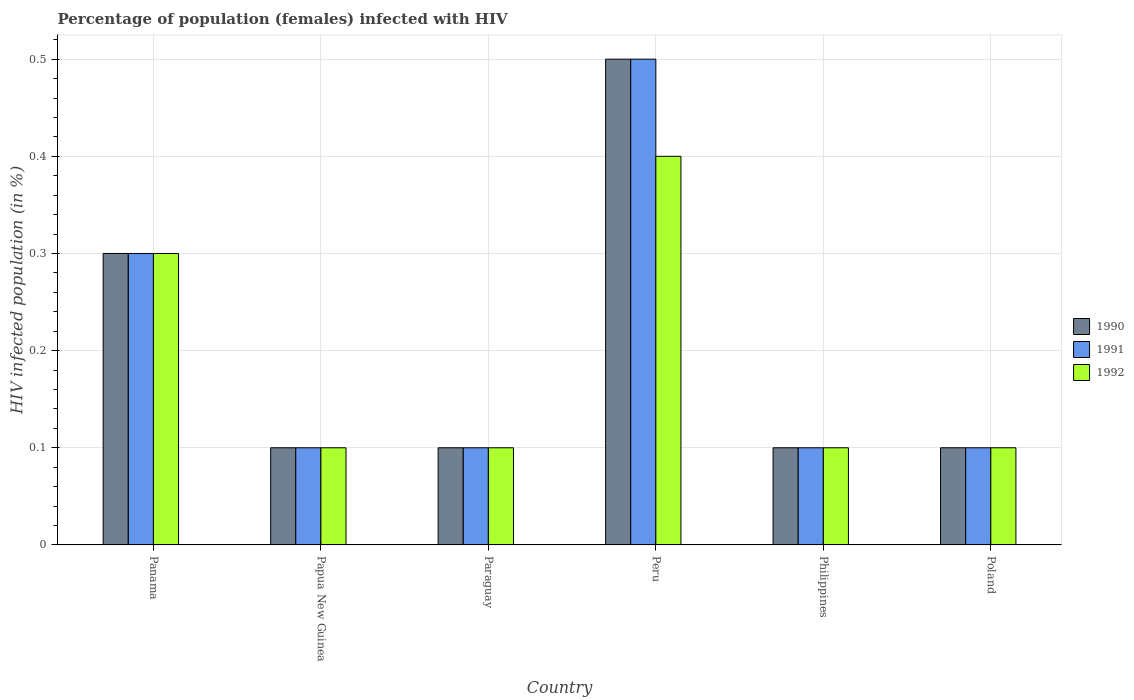How many different coloured bars are there?
Your answer should be compact. 3. What is the label of the 2nd group of bars from the left?
Ensure brevity in your answer.  Papua New Guinea. In how many cases, is the number of bars for a given country not equal to the number of legend labels?
Give a very brief answer. 0. Across all countries, what is the maximum percentage of HIV infected female population in 1990?
Provide a succinct answer. 0.5. In which country was the percentage of HIV infected female population in 1992 minimum?
Keep it short and to the point. Papua New Guinea. What is the average percentage of HIV infected female population in 1991 per country?
Your answer should be compact. 0.2. In how many countries, is the percentage of HIV infected female population in 1992 greater than 0.18 %?
Your response must be concise. 2. What is the ratio of the percentage of HIV infected female population in 1991 in Papua New Guinea to that in Philippines?
Keep it short and to the point. 1. What is the difference between the highest and the lowest percentage of HIV infected female population in 1992?
Your response must be concise. 0.3. In how many countries, is the percentage of HIV infected female population in 1992 greater than the average percentage of HIV infected female population in 1992 taken over all countries?
Your answer should be compact. 2. Is the sum of the percentage of HIV infected female population in 1991 in Panama and Paraguay greater than the maximum percentage of HIV infected female population in 1990 across all countries?
Keep it short and to the point. No. What does the 1st bar from the left in Peru represents?
Offer a terse response. 1990. What does the 2nd bar from the right in Paraguay represents?
Make the answer very short. 1991. How many bars are there?
Your answer should be very brief. 18. Are all the bars in the graph horizontal?
Ensure brevity in your answer.  No. Are the values on the major ticks of Y-axis written in scientific E-notation?
Provide a succinct answer. No. Where does the legend appear in the graph?
Provide a short and direct response. Center right. How are the legend labels stacked?
Provide a short and direct response. Vertical. What is the title of the graph?
Ensure brevity in your answer.  Percentage of population (females) infected with HIV. What is the label or title of the Y-axis?
Your answer should be compact. HIV infected population (in %). What is the HIV infected population (in %) of 1990 in Panama?
Give a very brief answer. 0.3. What is the HIV infected population (in %) of 1991 in Panama?
Ensure brevity in your answer.  0.3. What is the HIV infected population (in %) in 1992 in Panama?
Offer a terse response. 0.3. What is the HIV infected population (in %) in 1990 in Papua New Guinea?
Give a very brief answer. 0.1. What is the HIV infected population (in %) of 1991 in Papua New Guinea?
Your answer should be very brief. 0.1. What is the HIV infected population (in %) of 1992 in Papua New Guinea?
Your response must be concise. 0.1. What is the HIV infected population (in %) of 1990 in Paraguay?
Keep it short and to the point. 0.1. What is the HIV infected population (in %) of 1991 in Paraguay?
Provide a short and direct response. 0.1. What is the HIV infected population (in %) of 1990 in Peru?
Your answer should be compact. 0.5. What is the HIV infected population (in %) of 1992 in Peru?
Your answer should be very brief. 0.4. What is the HIV infected population (in %) of 1991 in Philippines?
Keep it short and to the point. 0.1. What is the HIV infected population (in %) in 1992 in Philippines?
Your answer should be very brief. 0.1. What is the HIV infected population (in %) of 1990 in Poland?
Provide a succinct answer. 0.1. What is the HIV infected population (in %) of 1992 in Poland?
Keep it short and to the point. 0.1. Across all countries, what is the maximum HIV infected population (in %) of 1990?
Keep it short and to the point. 0.5. Across all countries, what is the minimum HIV infected population (in %) in 1990?
Offer a very short reply. 0.1. Across all countries, what is the minimum HIV infected population (in %) of 1991?
Give a very brief answer. 0.1. What is the total HIV infected population (in %) of 1990 in the graph?
Make the answer very short. 1.2. What is the difference between the HIV infected population (in %) in 1990 in Panama and that in Peru?
Your response must be concise. -0.2. What is the difference between the HIV infected population (in %) in 1991 in Panama and that in Peru?
Offer a terse response. -0.2. What is the difference between the HIV infected population (in %) in 1992 in Panama and that in Philippines?
Your answer should be compact. 0.2. What is the difference between the HIV infected population (in %) of 1991 in Panama and that in Poland?
Ensure brevity in your answer.  0.2. What is the difference between the HIV infected population (in %) in 1992 in Papua New Guinea and that in Paraguay?
Give a very brief answer. 0. What is the difference between the HIV infected population (in %) in 1991 in Papua New Guinea and that in Peru?
Provide a short and direct response. -0.4. What is the difference between the HIV infected population (in %) in 1992 in Papua New Guinea and that in Peru?
Provide a short and direct response. -0.3. What is the difference between the HIV infected population (in %) in 1990 in Papua New Guinea and that in Philippines?
Offer a very short reply. 0. What is the difference between the HIV infected population (in %) in 1992 in Papua New Guinea and that in Philippines?
Provide a short and direct response. 0. What is the difference between the HIV infected population (in %) of 1992 in Papua New Guinea and that in Poland?
Make the answer very short. 0. What is the difference between the HIV infected population (in %) in 1990 in Paraguay and that in Peru?
Offer a terse response. -0.4. What is the difference between the HIV infected population (in %) of 1991 in Paraguay and that in Peru?
Provide a succinct answer. -0.4. What is the difference between the HIV infected population (in %) in 1992 in Paraguay and that in Peru?
Ensure brevity in your answer.  -0.3. What is the difference between the HIV infected population (in %) of 1991 in Paraguay and that in Poland?
Offer a very short reply. 0. What is the difference between the HIV infected population (in %) in 1992 in Peru and that in Philippines?
Your response must be concise. 0.3. What is the difference between the HIV infected population (in %) of 1991 in Peru and that in Poland?
Offer a very short reply. 0.4. What is the difference between the HIV infected population (in %) in 1992 in Peru and that in Poland?
Give a very brief answer. 0.3. What is the difference between the HIV infected population (in %) of 1990 in Philippines and that in Poland?
Offer a very short reply. 0. What is the difference between the HIV infected population (in %) of 1991 in Philippines and that in Poland?
Give a very brief answer. 0. What is the difference between the HIV infected population (in %) in 1992 in Philippines and that in Poland?
Ensure brevity in your answer.  0. What is the difference between the HIV infected population (in %) in 1991 in Panama and the HIV infected population (in %) in 1992 in Papua New Guinea?
Keep it short and to the point. 0.2. What is the difference between the HIV infected population (in %) of 1990 in Panama and the HIV infected population (in %) of 1991 in Peru?
Make the answer very short. -0.2. What is the difference between the HIV infected population (in %) in 1990 in Panama and the HIV infected population (in %) in 1992 in Peru?
Your answer should be very brief. -0.1. What is the difference between the HIV infected population (in %) of 1991 in Panama and the HIV infected population (in %) of 1992 in Peru?
Make the answer very short. -0.1. What is the difference between the HIV infected population (in %) of 1990 in Panama and the HIV infected population (in %) of 1991 in Philippines?
Ensure brevity in your answer.  0.2. What is the difference between the HIV infected population (in %) of 1990 in Panama and the HIV infected population (in %) of 1991 in Poland?
Your answer should be very brief. 0.2. What is the difference between the HIV infected population (in %) of 1990 in Papua New Guinea and the HIV infected population (in %) of 1991 in Philippines?
Offer a terse response. 0. What is the difference between the HIV infected population (in %) in 1990 in Papua New Guinea and the HIV infected population (in %) in 1992 in Philippines?
Offer a terse response. 0. What is the difference between the HIV infected population (in %) in 1990 in Papua New Guinea and the HIV infected population (in %) in 1992 in Poland?
Provide a short and direct response. 0. What is the difference between the HIV infected population (in %) in 1990 in Paraguay and the HIV infected population (in %) in 1992 in Peru?
Provide a short and direct response. -0.3. What is the difference between the HIV infected population (in %) in 1990 in Paraguay and the HIV infected population (in %) in 1991 in Poland?
Your answer should be very brief. 0. What is the difference between the HIV infected population (in %) in 1990 in Paraguay and the HIV infected population (in %) in 1992 in Poland?
Offer a terse response. 0. What is the difference between the HIV infected population (in %) in 1991 in Paraguay and the HIV infected population (in %) in 1992 in Poland?
Your answer should be very brief. 0. What is the difference between the HIV infected population (in %) in 1990 in Peru and the HIV infected population (in %) in 1991 in Philippines?
Your response must be concise. 0.4. What is the difference between the HIV infected population (in %) of 1990 in Peru and the HIV infected population (in %) of 1991 in Poland?
Provide a short and direct response. 0.4. What is the difference between the HIV infected population (in %) of 1991 in Peru and the HIV infected population (in %) of 1992 in Poland?
Keep it short and to the point. 0.4. What is the difference between the HIV infected population (in %) in 1990 in Philippines and the HIV infected population (in %) in 1991 in Poland?
Your answer should be compact. 0. What is the average HIV infected population (in %) of 1992 per country?
Provide a succinct answer. 0.18. What is the difference between the HIV infected population (in %) of 1990 and HIV infected population (in %) of 1991 in Panama?
Make the answer very short. 0. What is the difference between the HIV infected population (in %) of 1990 and HIV infected population (in %) of 1992 in Panama?
Your answer should be very brief. 0. What is the difference between the HIV infected population (in %) in 1991 and HIV infected population (in %) in 1992 in Panama?
Your response must be concise. 0. What is the difference between the HIV infected population (in %) of 1990 and HIV infected population (in %) of 1991 in Papua New Guinea?
Offer a terse response. 0. What is the difference between the HIV infected population (in %) in 1990 and HIV infected population (in %) in 1992 in Papua New Guinea?
Keep it short and to the point. 0. What is the difference between the HIV infected population (in %) of 1991 and HIV infected population (in %) of 1992 in Papua New Guinea?
Provide a succinct answer. 0. What is the difference between the HIV infected population (in %) in 1990 and HIV infected population (in %) in 1991 in Paraguay?
Offer a terse response. 0. What is the difference between the HIV infected population (in %) of 1990 and HIV infected population (in %) of 1992 in Paraguay?
Offer a terse response. 0. What is the difference between the HIV infected population (in %) of 1991 and HIV infected population (in %) of 1992 in Paraguay?
Keep it short and to the point. 0. What is the difference between the HIV infected population (in %) of 1990 and HIV infected population (in %) of 1992 in Peru?
Make the answer very short. 0.1. What is the difference between the HIV infected population (in %) of 1991 and HIV infected population (in %) of 1992 in Peru?
Ensure brevity in your answer.  0.1. What is the difference between the HIV infected population (in %) in 1990 and HIV infected population (in %) in 1991 in Philippines?
Offer a very short reply. 0. What is the difference between the HIV infected population (in %) of 1991 and HIV infected population (in %) of 1992 in Philippines?
Give a very brief answer. 0. What is the difference between the HIV infected population (in %) of 1990 and HIV infected population (in %) of 1992 in Poland?
Your answer should be very brief. 0. What is the ratio of the HIV infected population (in %) of 1992 in Panama to that in Papua New Guinea?
Provide a short and direct response. 3. What is the ratio of the HIV infected population (in %) of 1992 in Panama to that in Paraguay?
Your answer should be compact. 3. What is the ratio of the HIV infected population (in %) in 1991 in Panama to that in Philippines?
Offer a terse response. 3. What is the ratio of the HIV infected population (in %) of 1992 in Panama to that in Philippines?
Ensure brevity in your answer.  3. What is the ratio of the HIV infected population (in %) of 1991 in Panama to that in Poland?
Ensure brevity in your answer.  3. What is the ratio of the HIV infected population (in %) of 1990 in Papua New Guinea to that in Paraguay?
Provide a short and direct response. 1. What is the ratio of the HIV infected population (in %) in 1990 in Papua New Guinea to that in Peru?
Your answer should be compact. 0.2. What is the ratio of the HIV infected population (in %) in 1991 in Papua New Guinea to that in Peru?
Your answer should be compact. 0.2. What is the ratio of the HIV infected population (in %) of 1992 in Papua New Guinea to that in Peru?
Make the answer very short. 0.25. What is the ratio of the HIV infected population (in %) of 1990 in Papua New Guinea to that in Philippines?
Provide a short and direct response. 1. What is the ratio of the HIV infected population (in %) of 1991 in Papua New Guinea to that in Poland?
Provide a succinct answer. 1. What is the ratio of the HIV infected population (in %) in 1992 in Papua New Guinea to that in Poland?
Give a very brief answer. 1. What is the ratio of the HIV infected population (in %) in 1991 in Paraguay to that in Peru?
Keep it short and to the point. 0.2. What is the ratio of the HIV infected population (in %) in 1990 in Paraguay to that in Philippines?
Your response must be concise. 1. What is the ratio of the HIV infected population (in %) in 1992 in Paraguay to that in Poland?
Your response must be concise. 1. What is the ratio of the HIV infected population (in %) in 1990 in Peru to that in Philippines?
Your answer should be compact. 5. What is the ratio of the HIV infected population (in %) of 1991 in Peru to that in Philippines?
Offer a terse response. 5. What is the ratio of the HIV infected population (in %) of 1992 in Peru to that in Philippines?
Give a very brief answer. 4. What is the ratio of the HIV infected population (in %) of 1990 in Peru to that in Poland?
Keep it short and to the point. 5. What is the ratio of the HIV infected population (in %) of 1991 in Peru to that in Poland?
Your answer should be compact. 5. What is the ratio of the HIV infected population (in %) of 1992 in Peru to that in Poland?
Provide a succinct answer. 4. What is the ratio of the HIV infected population (in %) in 1991 in Philippines to that in Poland?
Provide a short and direct response. 1. What is the difference between the highest and the second highest HIV infected population (in %) of 1990?
Your response must be concise. 0.2. What is the difference between the highest and the second highest HIV infected population (in %) in 1992?
Provide a short and direct response. 0.1. What is the difference between the highest and the lowest HIV infected population (in %) of 1990?
Your response must be concise. 0.4. 